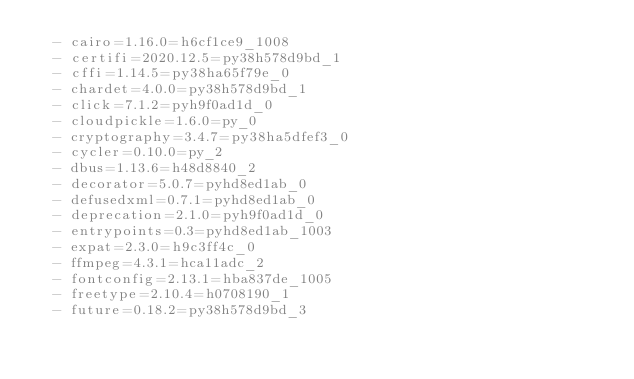<code> <loc_0><loc_0><loc_500><loc_500><_YAML_>  - cairo=1.16.0=h6cf1ce9_1008
  - certifi=2020.12.5=py38h578d9bd_1
  - cffi=1.14.5=py38ha65f79e_0
  - chardet=4.0.0=py38h578d9bd_1
  - click=7.1.2=pyh9f0ad1d_0
  - cloudpickle=1.6.0=py_0
  - cryptography=3.4.7=py38ha5dfef3_0
  - cycler=0.10.0=py_2
  - dbus=1.13.6=h48d8840_2
  - decorator=5.0.7=pyhd8ed1ab_0
  - defusedxml=0.7.1=pyhd8ed1ab_0
  - deprecation=2.1.0=pyh9f0ad1d_0
  - entrypoints=0.3=pyhd8ed1ab_1003
  - expat=2.3.0=h9c3ff4c_0
  - ffmpeg=4.3.1=hca11adc_2
  - fontconfig=2.13.1=hba837de_1005
  - freetype=2.10.4=h0708190_1
  - future=0.18.2=py38h578d9bd_3</code> 